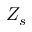Convert formula to latex. <formula><loc_0><loc_0><loc_500><loc_500>Z _ { s }</formula> 